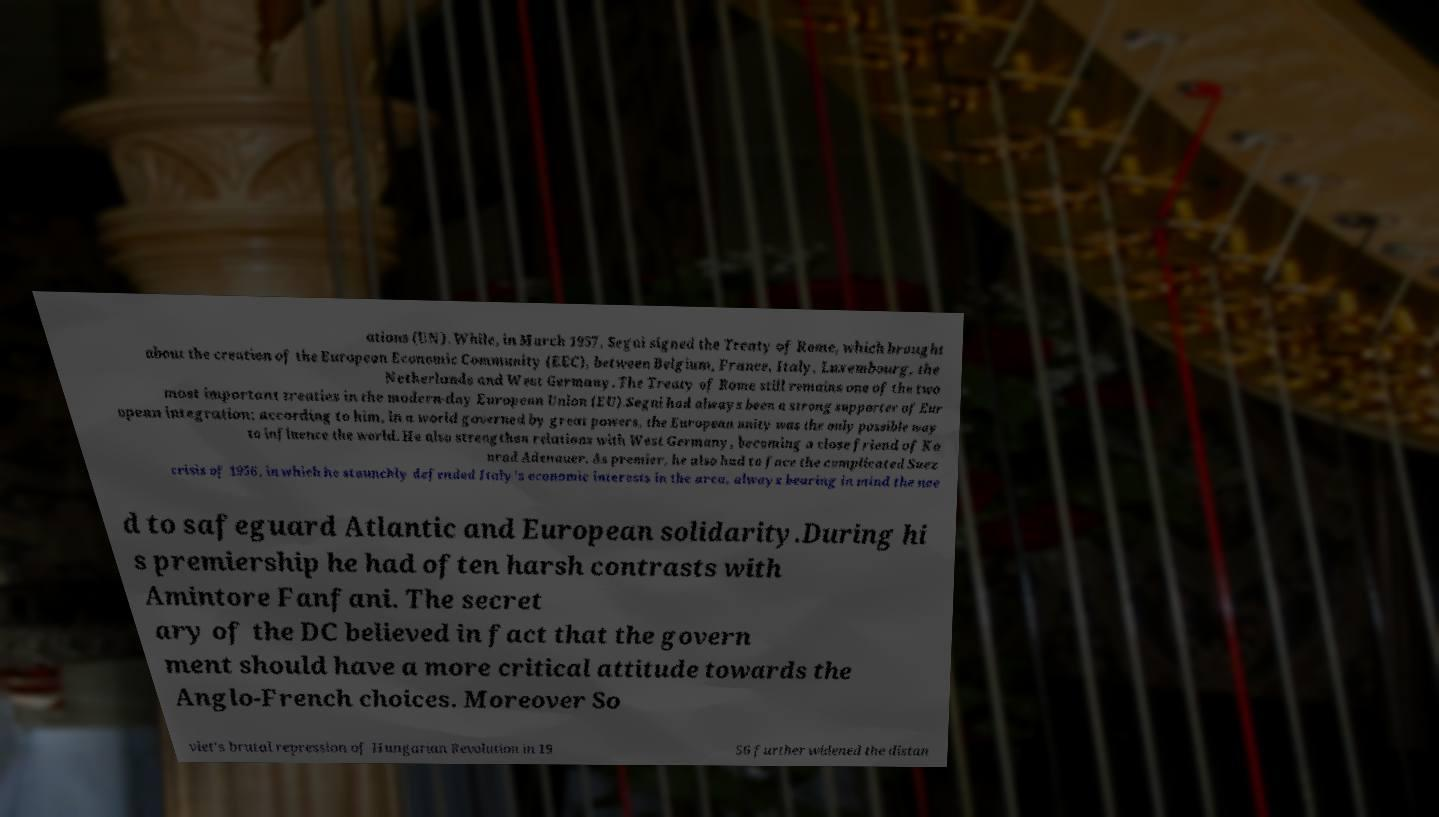For documentation purposes, I need the text within this image transcribed. Could you provide that? ations (UN). While, in March 1957, Segni signed the Treaty of Rome, which brought about the creation of the European Economic Community (EEC), between Belgium, France, Italy, Luxembourg, the Netherlands and West Germany. The Treaty of Rome still remains one of the two most important treaties in the modern-day European Union (EU).Segni had always been a strong supporter of Eur opean integration; according to him, in a world governed by great powers, the European unity was the only possible way to influence the world. He also strengthen relations with West Germany, becoming a close friend of Ko nrad Adenauer. As premier, he also had to face the complicated Suez crisis of 1956, in which he staunchly defended Italy's economic interests in the area, always bearing in mind the nee d to safeguard Atlantic and European solidarity.During hi s premiership he had often harsh contrasts with Amintore Fanfani. The secret ary of the DC believed in fact that the govern ment should have a more critical attitude towards the Anglo-French choices. Moreover So viet's brutal repression of Hungarian Revolution in 19 56 further widened the distan 